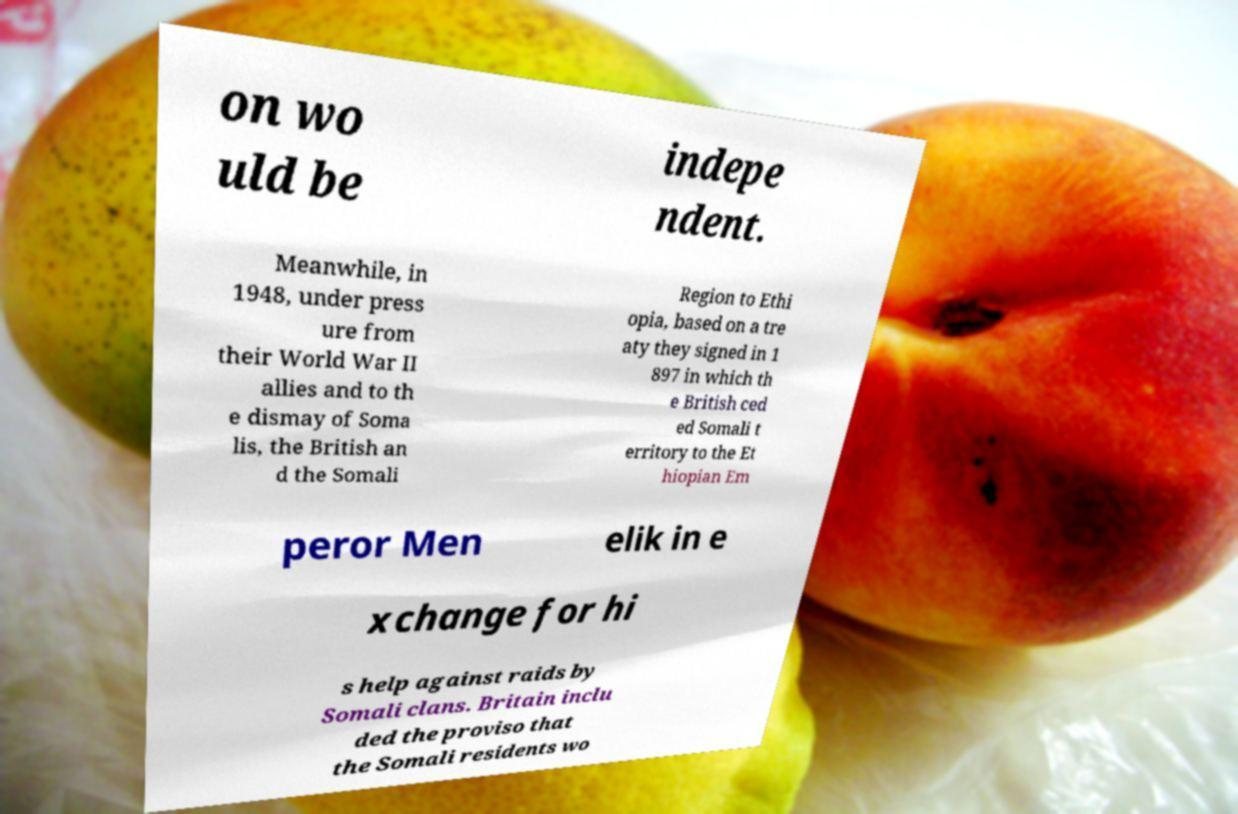What messages or text are displayed in this image? I need them in a readable, typed format. on wo uld be indepe ndent. Meanwhile, in 1948, under press ure from their World War II allies and to th e dismay of Soma lis, the British an d the Somali Region to Ethi opia, based on a tre aty they signed in 1 897 in which th e British ced ed Somali t erritory to the Et hiopian Em peror Men elik in e xchange for hi s help against raids by Somali clans. Britain inclu ded the proviso that the Somali residents wo 